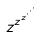Convert formula to latex. <formula><loc_0><loc_0><loc_500><loc_500>z ^ { z ^ { z ^ { \cdot ^ { \cdot ^ { \cdot } } } } }</formula> 